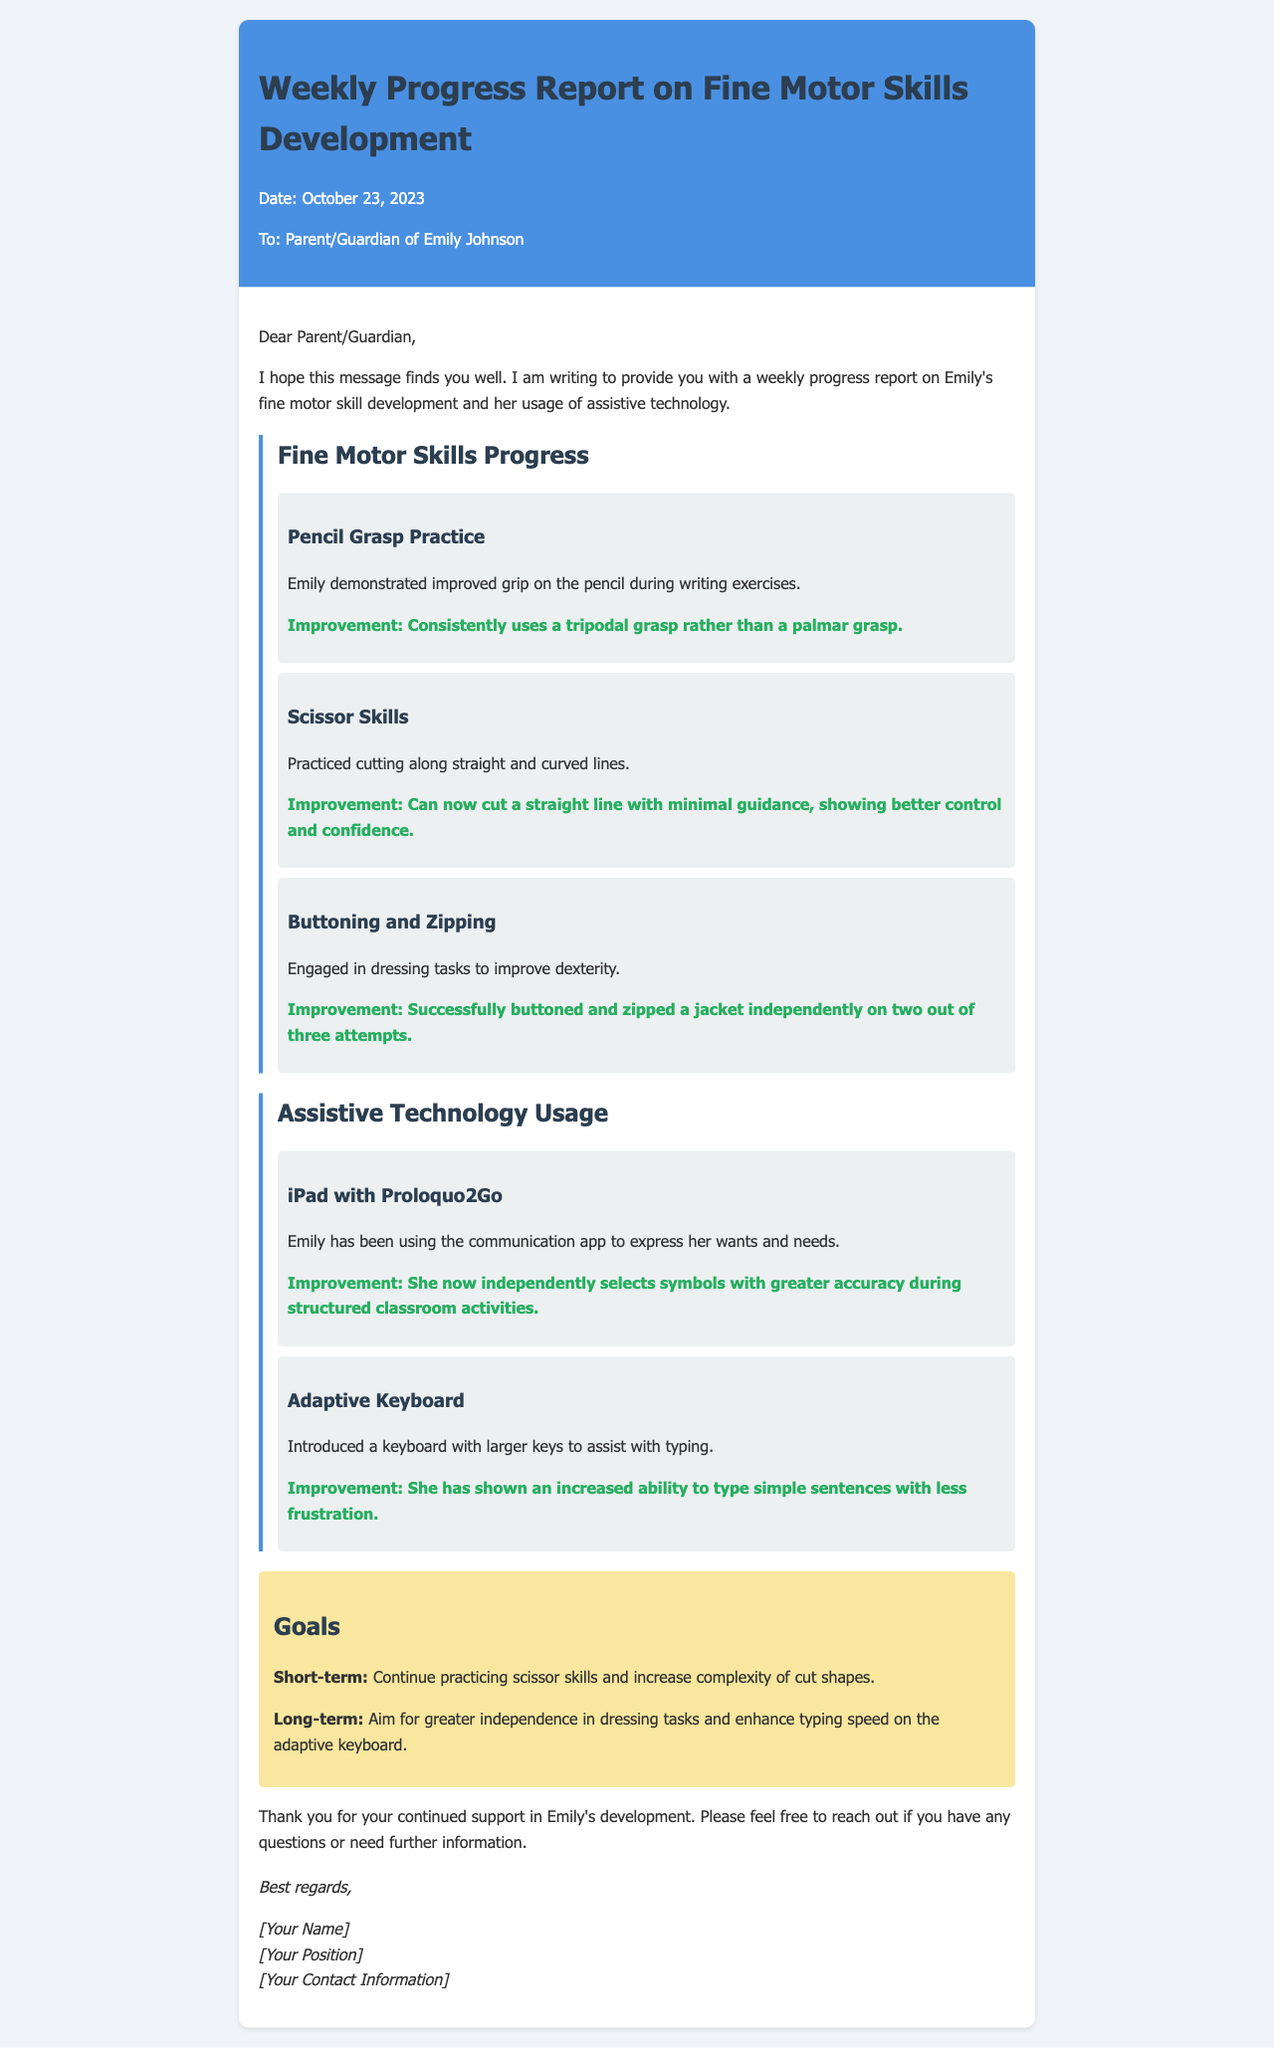What is the date of the report? The report is dated October 23, 2023 as mentioned in the document header.
Answer: October 23, 2023 Who is the student mentioned in the report? The student referred to in the report is Emily Johnson, as stated at the beginning of the document.
Answer: Emily Johnson How many attempts did Emily successfully button and zip a jacket independently? Emily succeeded in buttoning and zipping a jacket on two out of three attempts, as highlighted in the section about dressing tasks.
Answer: Two out of three What improvement did Emily show in scissor skills? The document states that she can cut a straight line with minimal guidance, reflecting better control and confidence in her scissor skills.
Answer: Can cut a straight line with minimal guidance What is one of the short-term goals stated in the report? The short-term goal includes continuing to practice scissor skills and increasing the complexity of cut shapes as mentioned in the goals section.
Answer: Continue practicing scissor skills What technology is mentioned to assist with typing? The adaptive keyboard is introduced in the document to assist Emily with typing tasks.
Answer: Adaptive keyboard Which app is used by Emily for communication? Emily uses the Proloquo2Go app on her iPad to express her wants and needs, as noted in the assistive technology section.
Answer: Proloquo2Go What was Emily’s interaction level with the symbols during structured classroom activities? Emily now independently selects symbols with greater accuracy, indicating an improved interaction level during classroom activities.
Answer: Independently selects symbols with greater accuracy What position does the author of the report hold? The document prompts for the author’s position but does not specify it directly, leading to potential inquiry about their role.
Answer: [Your Position] 